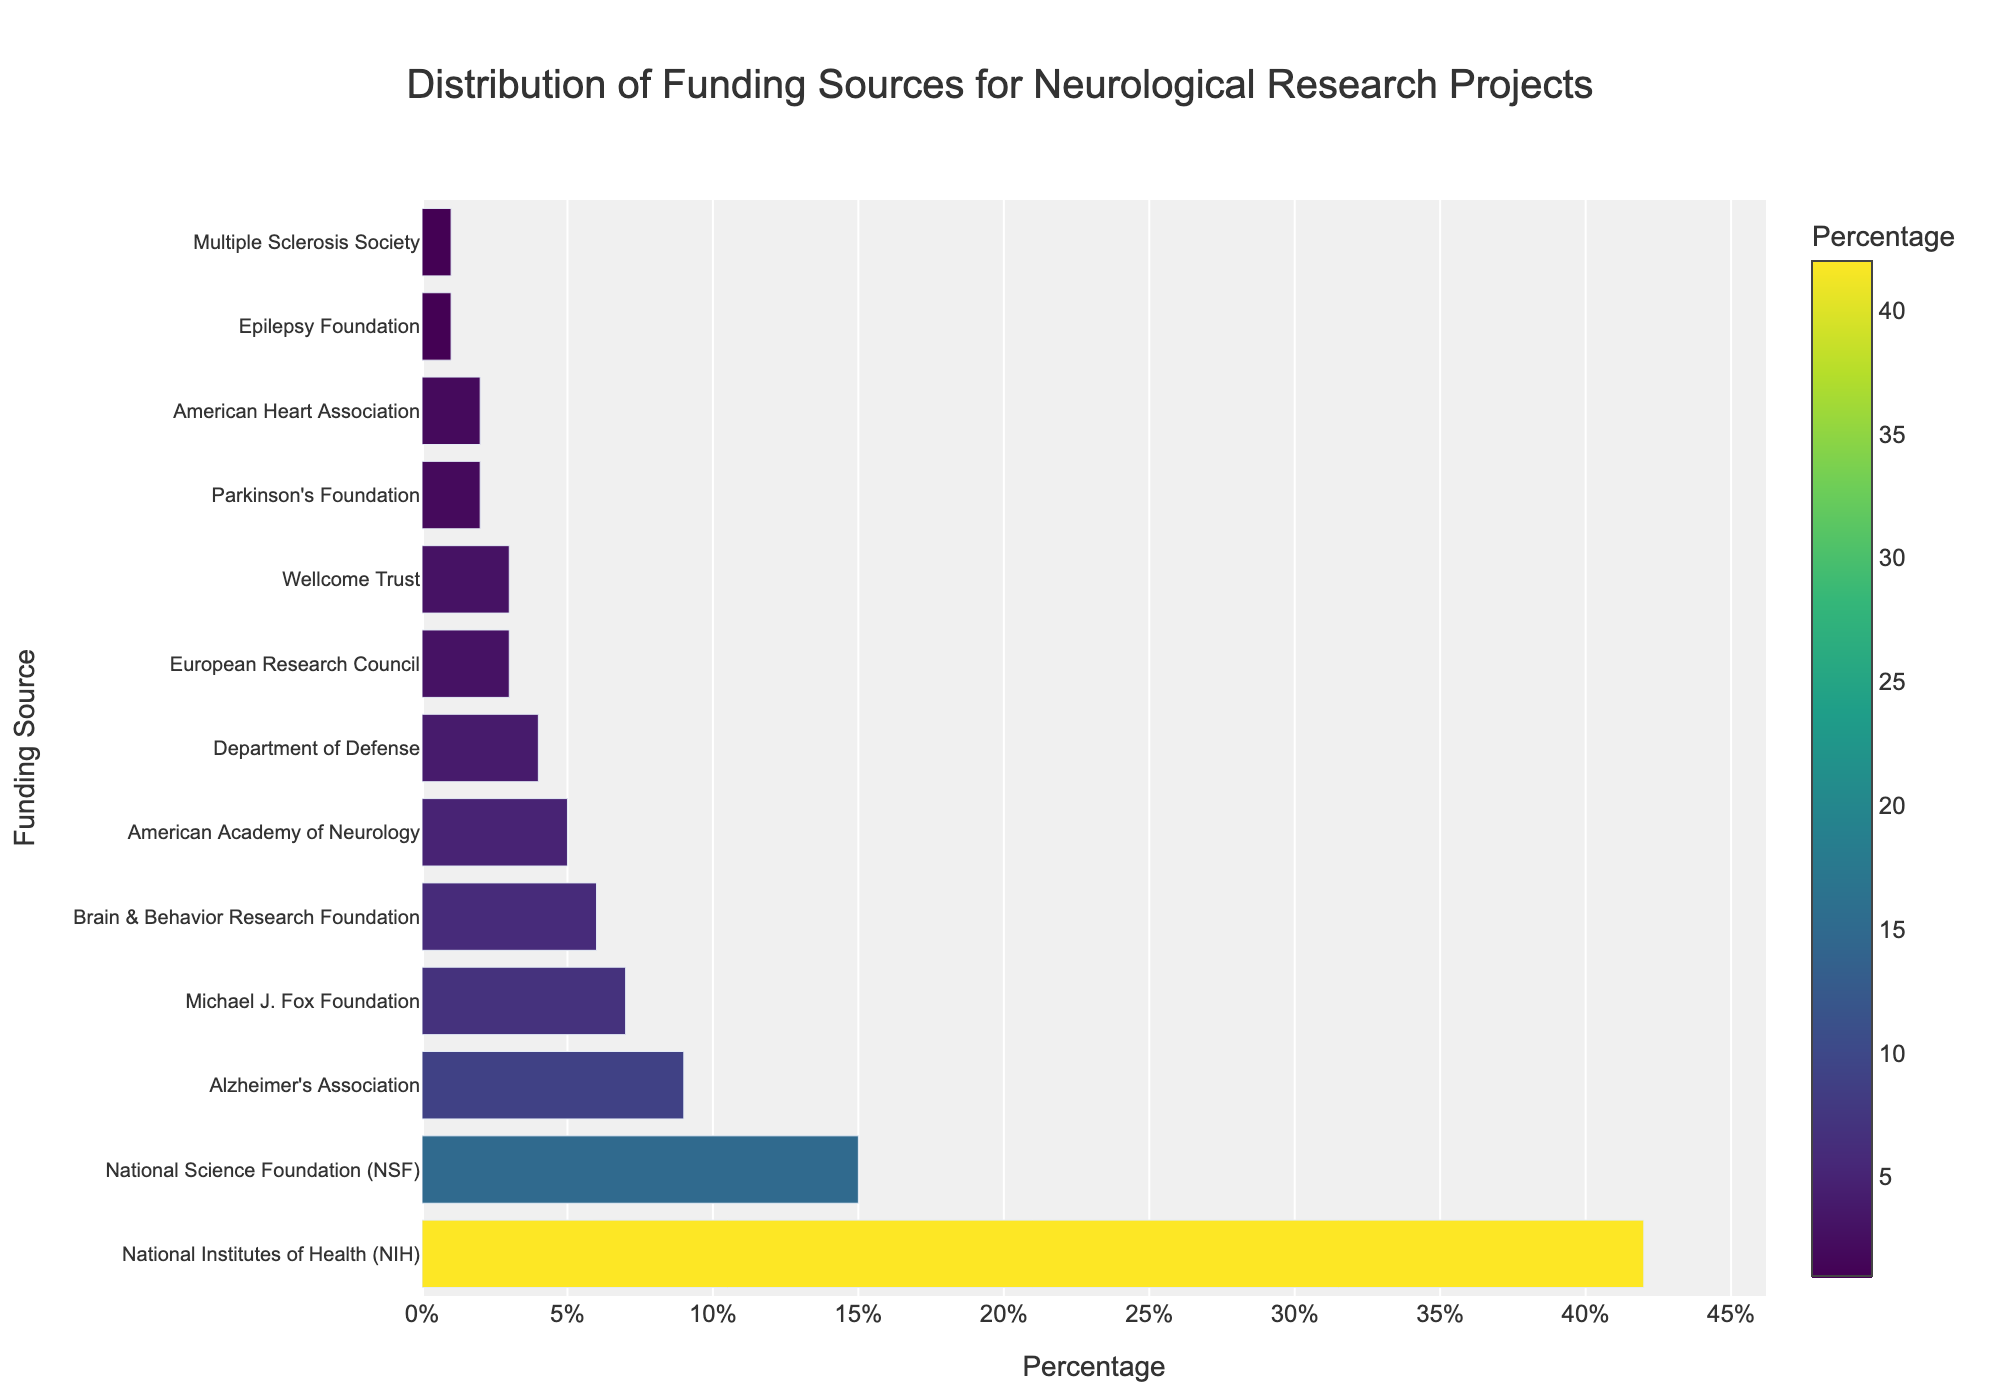What is the percentage of funding from the National Institutes of Health (NIH)? The length of the bar representing the National Institutes of Health (NIH) on the chart extends to 42% on the x-axis.
Answer: 42% Which funding source contributes the least to neurological research projects? The shortest bar on the chart belongs to the Epilepsy Foundation and the Multiple Sclerosis Society, both at 1%.
Answer: Epilepsy Foundation, Multiple Sclerosis Society Which funding source has a higher percentage, Alzheimer's Association or Michael J. Fox Foundation? Comparing the bars, the bar for Alzheimer's Association extends to 9%, while the bar for Michael J. Fox Foundation extends to 7%.
Answer: Alzheimer's Association Sum the percentages of funding from the American Academy of Neurology, Department of Defense, and European Research Council. The percentages are 5% for the American Academy of Neurology, 4% for the Department of Defense, and 3% for the European Research Council. Summing these: 5 + 4 + 3 = 12.
Answer: 12% What is the difference in percentage points between the highest and the lowest funding sources? The highest funding source (National Institutes of Health) contributes 42%, while the lowest sources (Epilepsy Foundation and Multiple Sclerosis Society) contribute 1%. The difference is 42 - 1 = 41.
Answer: 41% Which funding sources contribute exactly 3%? The bars representing the European Research Council and Wellcome Trust both extend to 3% on the x-axis.
Answer: European Research Council, Wellcome Trust What percentage of funding is collectively contributed by the Parkinson's Foundation and the American Heart Association? The percentage for the Parkinson's Foundation is 2%, and for the American Heart Association, it is also 2%. Summing these gives 2 + 2 = 4.
Answer: 4% Compare the funding contributions of the National Institutes of Health (NIH) and the National Science Foundation (NSF). What's the ratio of NIH to NSF? The NIH contributes 42%, and the NSF contributes 15%. The ratio of NIH to NSF is 42:15, which simplifies to 42/15 = 2.8.
Answer: 2.8 Identify the funding source that is the closest in percentage to the American Academy of Neurology. The American Academy of Neurology contributes 5%. The closest in percentage among the listed sources is the Brain & Behavior Research Foundation, which contributes 6%.
Answer: Brain & Behavior Research Foundation 